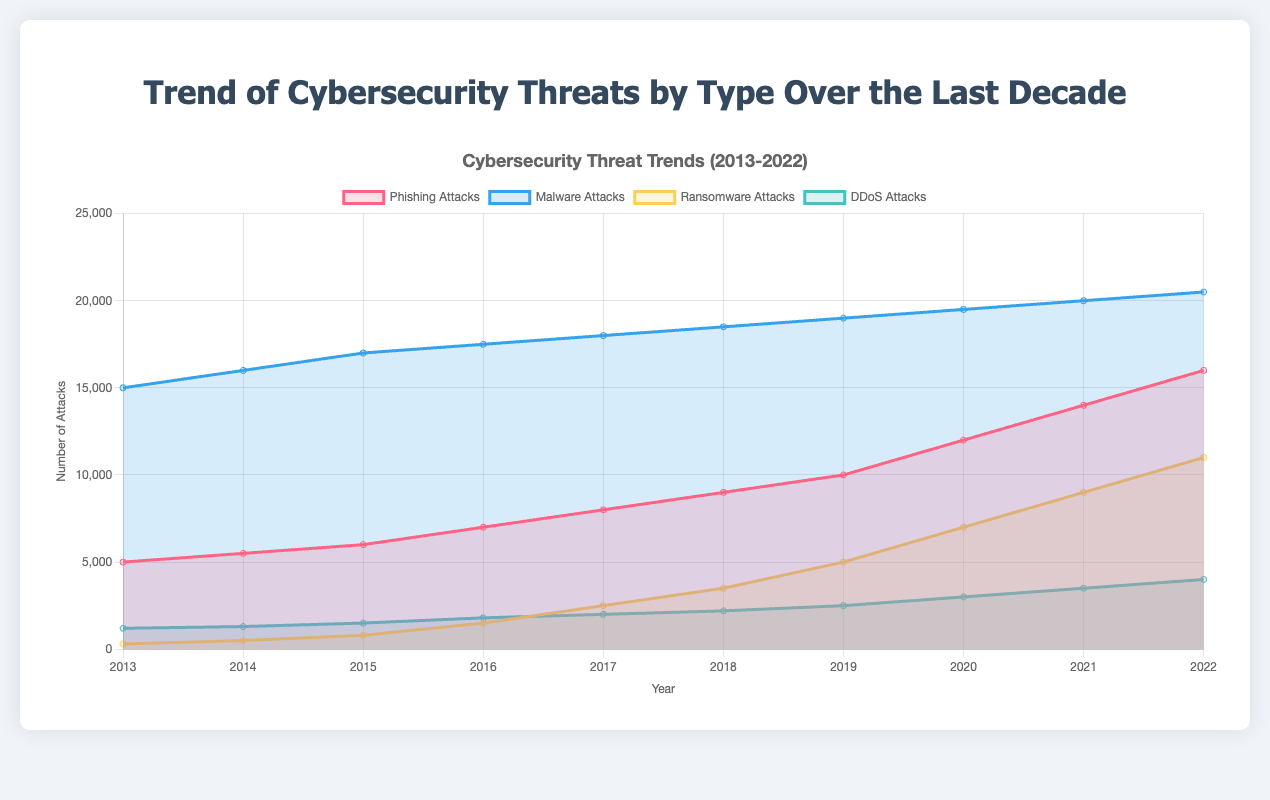What is the title of the chart? The title is displayed at the top of the chart and provides a summary of what the chart represents. In this case, it says "Trend of Cybersecurity Threats by Type Over the Last Decade".
Answer: Trend of Cybersecurity Threats by Type Over the Last Decade What is the y-axis label? The y-axis label indicates the measurement unit for the data plotted on the y-axis. It is shown as "Number of Attacks".
Answer: Number of Attacks Which type of cybersecurity attack has shown the highest growth from 2013 to 2022? We need to look at the increase in attack numbers for each type from 2013 to 2022. Ransomware Attacks increased from 300 to 11000, showing the highest growth.
Answer: Ransomware Attacks In which year did phishing attacks exceed 10,000 for the first time? We locate the point where the Phishing Attacks line crosses over 10,000 on the y-axis, which happens in the year 2019.
Answer: 2019 What is the overall trend of Malware Attacks over the years? Observing the Malware Attacks line, we see it gradually increases from 15000 in 2013 to 20500 in 2022, indicating a steadily increasing trend.
Answer: Increasing By how much did DDoS attacks increase between 2017 and 2022? We subtract the number of DDoS Attacks in 2017 (2000) from the number in 2022 (4000), resulting in an increase of 2000.
Answer: 2000 Which year saw the largest single-year increase in Ransomware Attacks? We calculate the year-over-year increase for Ransomware Attacks. The largest increase happens between 2019 (5000) and 2020 (7000), an increase of 2000.
Answer: 2020 Compare the number of Malware Attacks and Phishing Attacks in 2016. Which one was higher and by how much? In 2016, Malware Attacks were 17500, and Phishing Attacks were 7000. Therefore, Malware Attacks were higher by 17500 - 7000 = 10500.
Answer: Malware, 10500 What general observation can be made about the trend of phishing attacks from 2013 to 2022? From the graph, the number of Phishing Attacks is shown to consistently increase every year from 5000 in 2013 to 16000 in 2022, indicating a steady upward trend.
Answer: Steadily increasing What is the total number of attacks for all types combined in 2021? Sum the attacks of all types in 2021: Phishing (14000) + Malware (20000) + Ransomware (9000) + DDoS (3500) = 46500.
Answer: 46500 